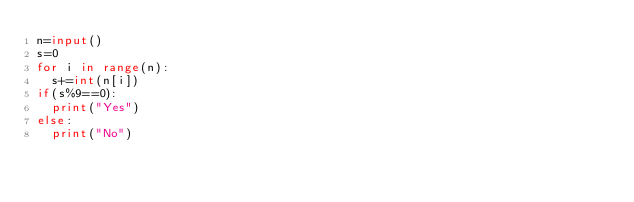<code> <loc_0><loc_0><loc_500><loc_500><_Python_>n=input()
s=0
for i in range(n):
  s+=int(n[i])
if(s%9==0):
  print("Yes")
else:
  print("No")</code> 